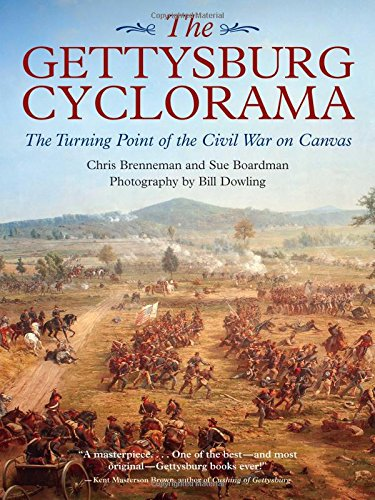Who are the other contributors involved in the creation of this book? Apart from Chris Brenneman, Sue Boardman, a historian and cyclorama expert, co-authored the book. Additionally, Bill Dowling provided the photography, capturing detailed images of the cyclorama painting. 